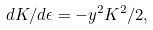Convert formula to latex. <formula><loc_0><loc_0><loc_500><loc_500>d K / d \epsilon = - y ^ { 2 } K ^ { 2 } / 2 ,</formula> 